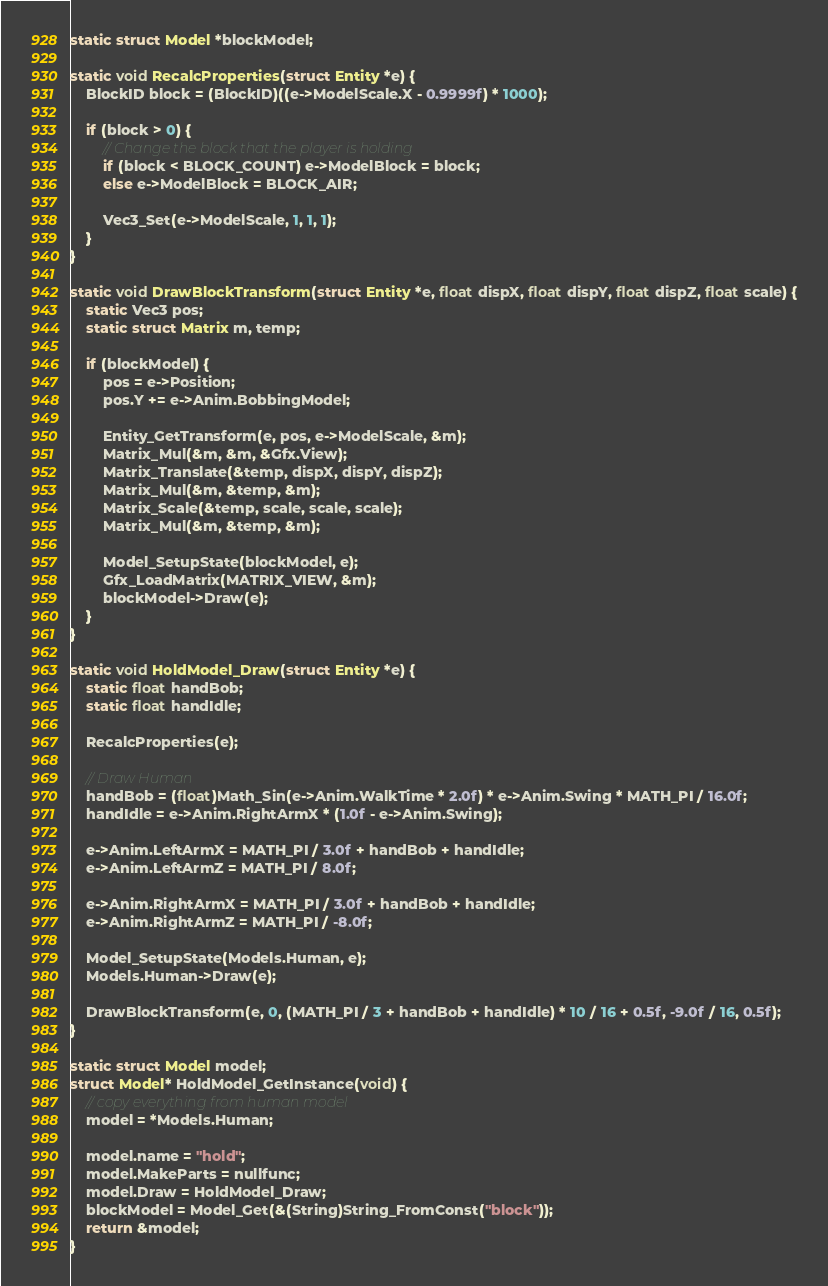<code> <loc_0><loc_0><loc_500><loc_500><_C_>static struct Model *blockModel;

static void RecalcProperties(struct Entity *e) {
	BlockID block = (BlockID)((e->ModelScale.X - 0.9999f) * 1000);

	if (block > 0) {
		// Change the block that the player is holding
		if (block < BLOCK_COUNT) e->ModelBlock = block;
		else e->ModelBlock = BLOCK_AIR;

		Vec3_Set(e->ModelScale, 1, 1, 1);
	}
}

static void DrawBlockTransform(struct Entity *e, float dispX, float dispY, float dispZ, float scale) {
	static Vec3 pos;
	static struct Matrix m, temp;

	if (blockModel) {
		pos = e->Position;
		pos.Y += e->Anim.BobbingModel;

		Entity_GetTransform(e, pos, e->ModelScale, &m);
		Matrix_Mul(&m, &m, &Gfx.View);
		Matrix_Translate(&temp, dispX, dispY, dispZ);
		Matrix_Mul(&m, &temp, &m);
		Matrix_Scale(&temp, scale, scale, scale);
		Matrix_Mul(&m, &temp, &m);

		Model_SetupState(blockModel, e);
		Gfx_LoadMatrix(MATRIX_VIEW, &m);
		blockModel->Draw(e);
	}
}

static void HoldModel_Draw(struct Entity *e) {
	static float handBob;
	static float handIdle;

	RecalcProperties(e);

	// Draw Human
	handBob = (float)Math_Sin(e->Anim.WalkTime * 2.0f) * e->Anim.Swing * MATH_PI / 16.0f;
	handIdle = e->Anim.RightArmX * (1.0f - e->Anim.Swing);

	e->Anim.LeftArmX = MATH_PI / 3.0f + handBob + handIdle;
	e->Anim.LeftArmZ = MATH_PI / 8.0f;

	e->Anim.RightArmX = MATH_PI / 3.0f + handBob + handIdle;
	e->Anim.RightArmZ = MATH_PI / -8.0f;

	Model_SetupState(Models.Human, e);
	Models.Human->Draw(e);
	
	DrawBlockTransform(e, 0, (MATH_PI / 3 + handBob + handIdle) * 10 / 16 + 0.5f, -9.0f / 16, 0.5f);
}

static struct Model model;
struct Model* HoldModel_GetInstance(void) {
	// copy everything from human model
	model = *Models.Human;

	model.name = "hold";
	model.MakeParts = nullfunc;
	model.Draw = HoldModel_Draw;
	blockModel = Model_Get(&(String)String_FromConst("block"));
	return &model;
}</code> 